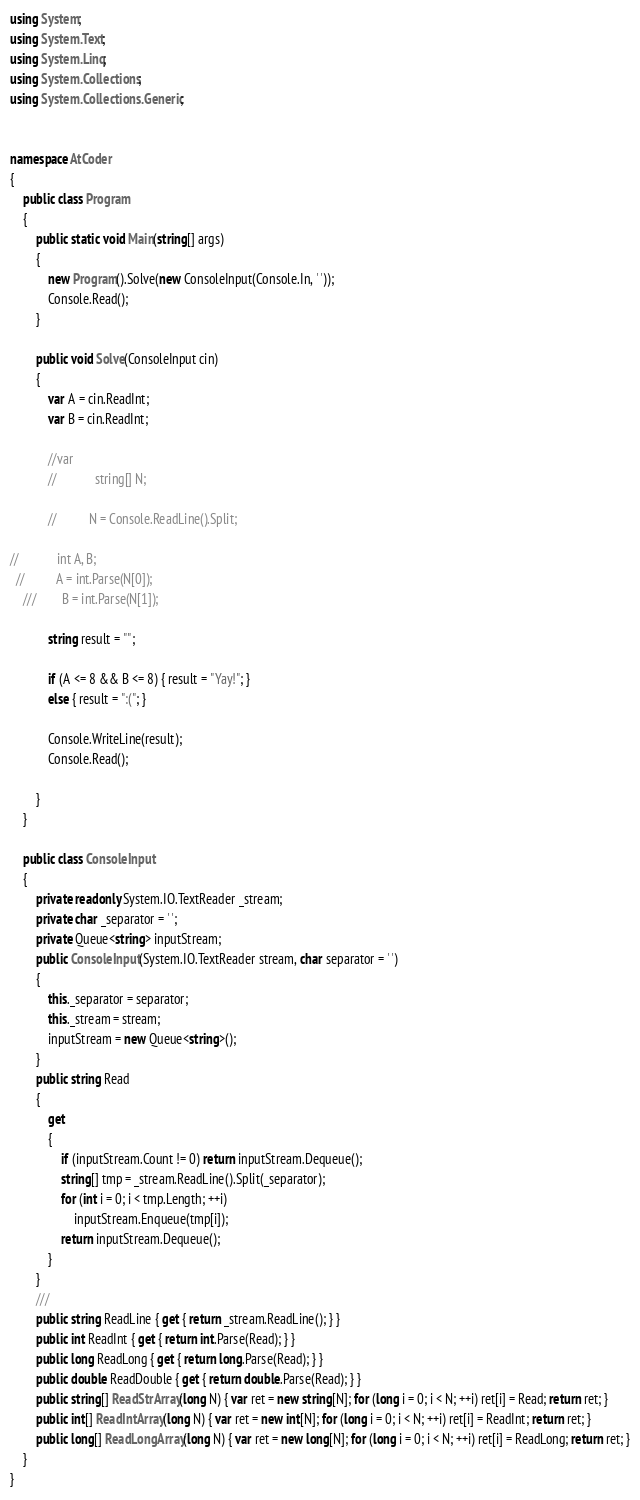<code> <loc_0><loc_0><loc_500><loc_500><_C#_>using System;
using System.Text;
using System.Linq;
using System.Collections;
using System.Collections.Generic;


namespace AtCoder
{
    public class Program
    {
        public static void Main(string[] args)
        {
            new Program().Solve(new ConsoleInput(Console.In, ' '));
            Console.Read();
        }

        public void Solve(ConsoleInput cin)
        {
            var A = cin.ReadInt;
            var B = cin.ReadInt;

            //var 
            //            string[] N;

            //          N = Console.ReadLine().Split;

//            int A, B;
  //          A = int.Parse(N[0]);
    ///        B = int.Parse(N[1]);

            string result = "";

            if (A <= 8 && B <= 8) { result = "Yay!"; }
            else { result = ":("; }

            Console.WriteLine(result);
            Console.Read();

        }
    }

    public class ConsoleInput
    {
        private readonly System.IO.TextReader _stream;
        private char _separator = ' ';
        private Queue<string> inputStream;
        public ConsoleInput(System.IO.TextReader stream, char separator = ' ')
        {
            this._separator = separator;
            this._stream = stream;
            inputStream = new Queue<string>();
        }
        public string Read
        {
            get
            {
                if (inputStream.Count != 0) return inputStream.Dequeue();
                string[] tmp = _stream.ReadLine().Split(_separator);
                for (int i = 0; i < tmp.Length; ++i)
                    inputStream.Enqueue(tmp[i]);
                return inputStream.Dequeue();
            }
        }
        ///
        public string ReadLine { get { return _stream.ReadLine(); } }
        public int ReadInt { get { return int.Parse(Read); } }
        public long ReadLong { get { return long.Parse(Read); } }
        public double ReadDouble { get { return double.Parse(Read); } }
        public string[] ReadStrArray(long N) { var ret = new string[N]; for (long i = 0; i < N; ++i) ret[i] = Read; return ret; }
        public int[] ReadIntArray(long N) { var ret = new int[N]; for (long i = 0; i < N; ++i) ret[i] = ReadInt; return ret; }
        public long[] ReadLongArray(long N) { var ret = new long[N]; for (long i = 0; i < N; ++i) ret[i] = ReadLong; return ret; }
    }
}</code> 